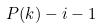<formula> <loc_0><loc_0><loc_500><loc_500>P ( k ) - i - 1</formula> 